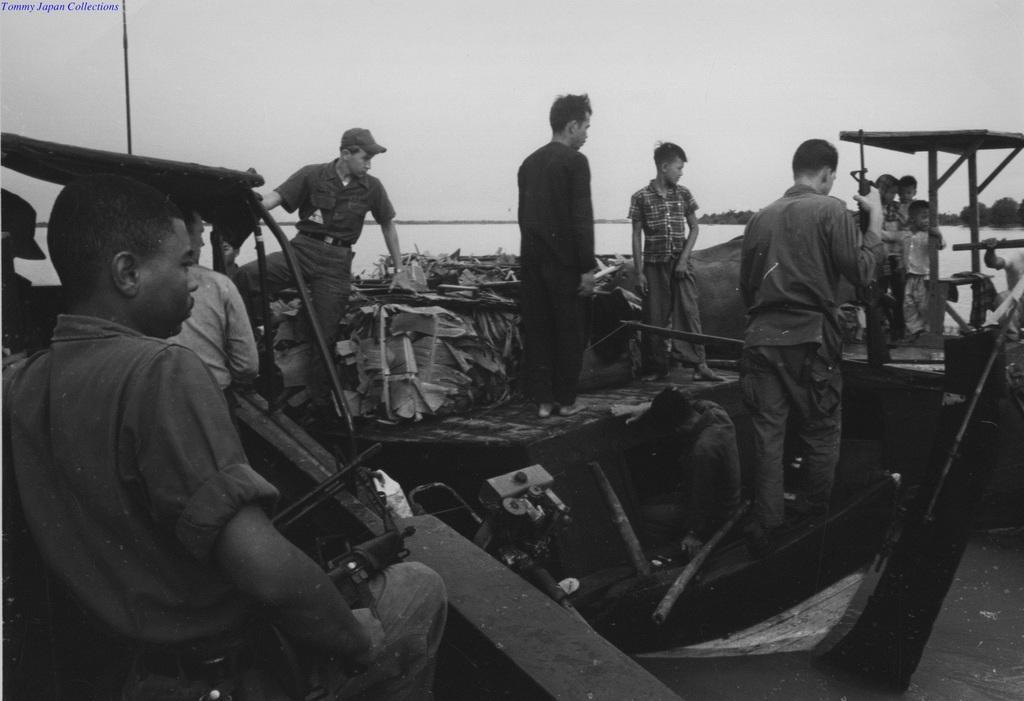Please provide a concise description of this image. In this picture we can see a group of people, here we can see some objects and in the background we can see water, trees, sky, in the top left we can see some text on it. 